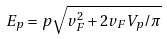<formula> <loc_0><loc_0><loc_500><loc_500>E _ { p } = p \sqrt { v _ { F } ^ { 2 } + 2 v _ { F } V _ { p } / \pi }</formula> 